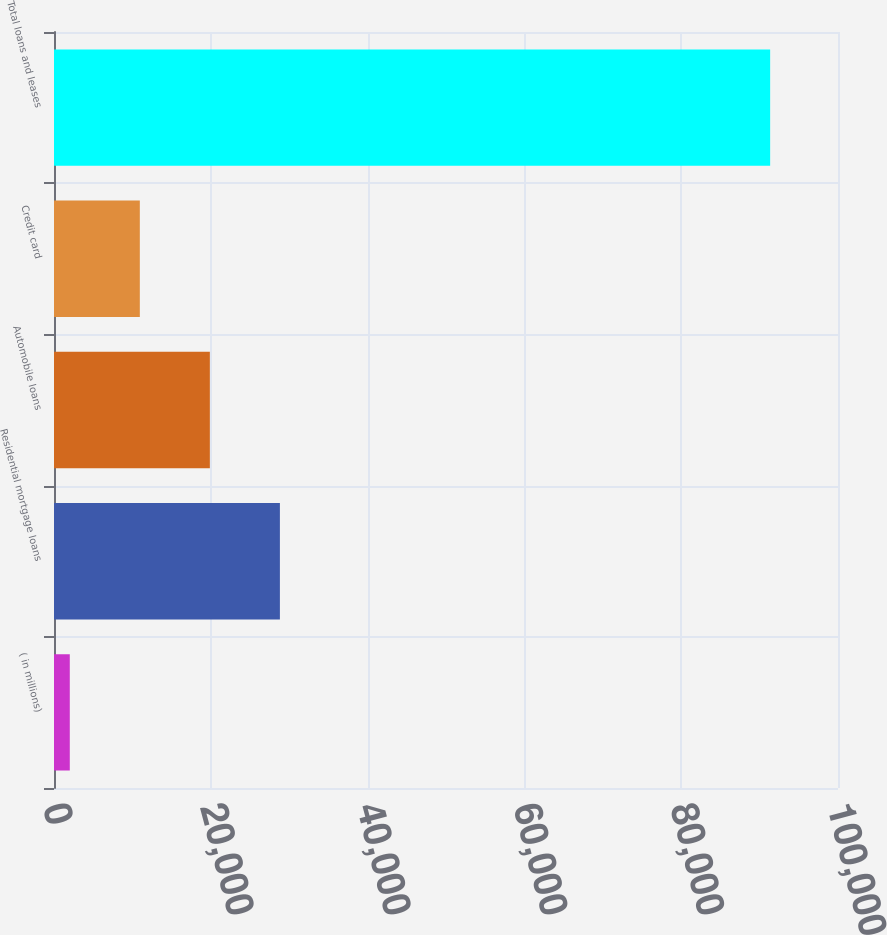Convert chart to OTSL. <chart><loc_0><loc_0><loc_500><loc_500><bar_chart><fcel>( in millions)<fcel>Residential mortgage loans<fcel>Automobile loans<fcel>Credit card<fcel>Total loans and leases<nl><fcel>2014<fcel>28813.3<fcel>19880.2<fcel>10947.1<fcel>91345<nl></chart> 